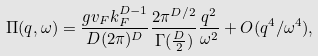<formula> <loc_0><loc_0><loc_500><loc_500>\Pi ( q , \omega ) = \frac { g v _ { F } k _ { F } ^ { D - 1 } } { D ( 2 \pi ) ^ { D } } \frac { 2 \pi ^ { D / 2 } } { \Gamma ( \frac { D } { 2 } ) } \frac { q ^ { 2 } } { \omega ^ { 2 } } + O ( q ^ { 4 } / \omega ^ { 4 } ) ,</formula> 